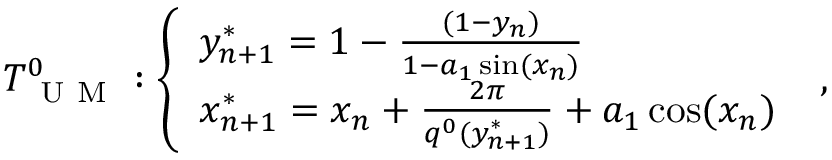Convert formula to latex. <formula><loc_0><loc_0><loc_500><loc_500>T _ { U M } ^ { 0 } \colon \left \{ \begin{array} { l l } { y _ { n + 1 } ^ { * } = 1 - \frac { ( 1 - y _ { n } ) } { 1 - a _ { 1 } \sin ( x _ { n } ) } } \\ { x _ { n + 1 } ^ { * } = x _ { n } + \frac { 2 \pi } { q ^ { 0 } ( y _ { n + 1 } ^ { * } ) } + a _ { 1 } \cos ( x _ { n } ) } \end{array} ,</formula> 